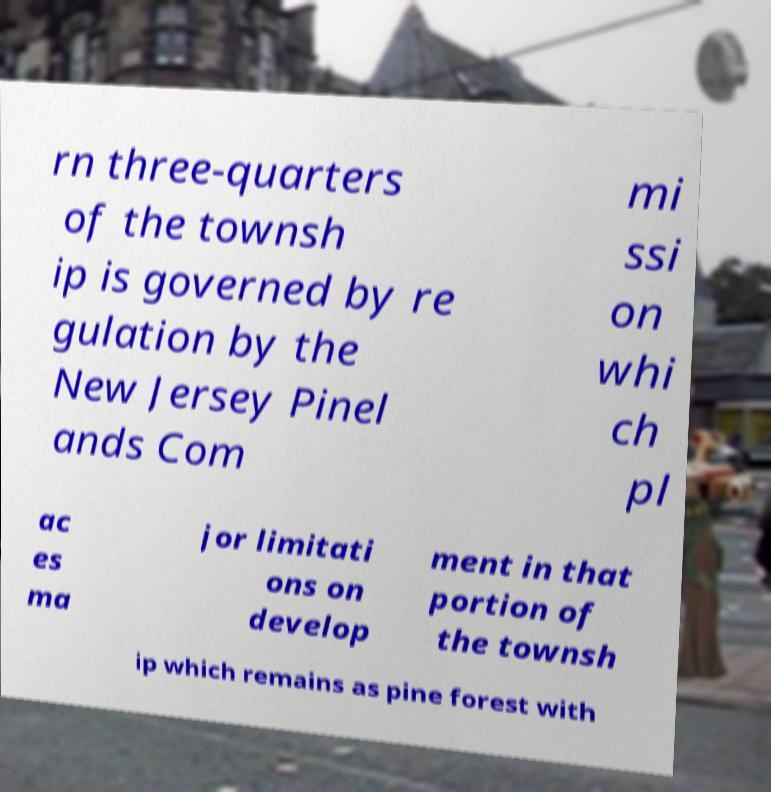Could you assist in decoding the text presented in this image and type it out clearly? rn three-quarters of the townsh ip is governed by re gulation by the New Jersey Pinel ands Com mi ssi on whi ch pl ac es ma jor limitati ons on develop ment in that portion of the townsh ip which remains as pine forest with 